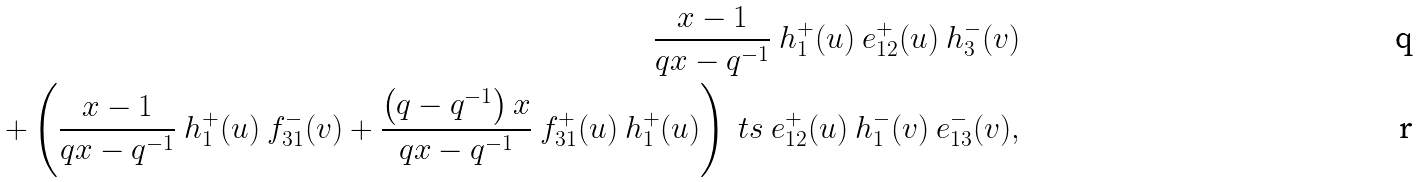<formula> <loc_0><loc_0><loc_500><loc_500>\frac { x - 1 } { q x - q ^ { - 1 } } \ h _ { 1 } ^ { + } ( u ) \ e _ { 1 2 } ^ { + } ( u ) \ h _ { 3 } ^ { - } ( v ) \\ + \left ( \frac { x - 1 } { q x - q ^ { - 1 } } \ h _ { 1 } ^ { + } ( u ) \ f _ { 3 1 } ^ { - } ( v ) + \frac { \left ( q - q ^ { - 1 } \right ) x } { q x - q ^ { - 1 } } \ f _ { 3 1 } ^ { + } ( u ) \ h _ { 1 } ^ { + } ( u ) \right ) \ t s \ e _ { 1 2 } ^ { + } ( u ) \ h _ { 1 } ^ { - } ( v ) \ e _ { 1 3 } ^ { - } ( v ) ,</formula> 